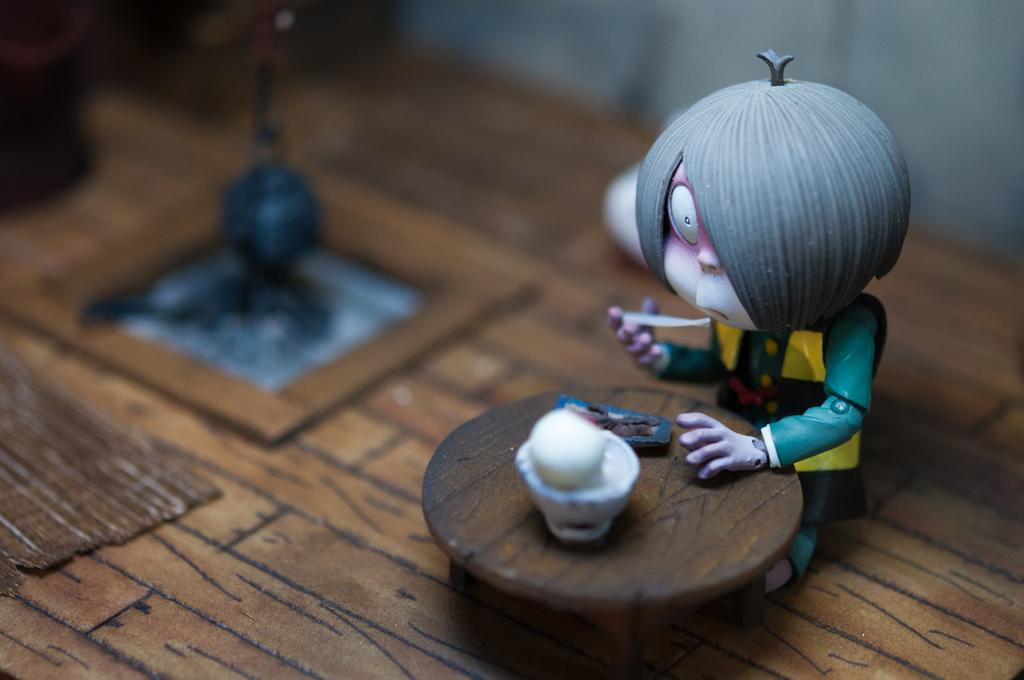What is the main subject in the image? There is a doll in the image. What else can be seen in the image besides the doll? There is a small table in the image. What type of trouble is the doll causing on the coast in the image? There is no coast present in the image, and the doll is not causing any trouble. 